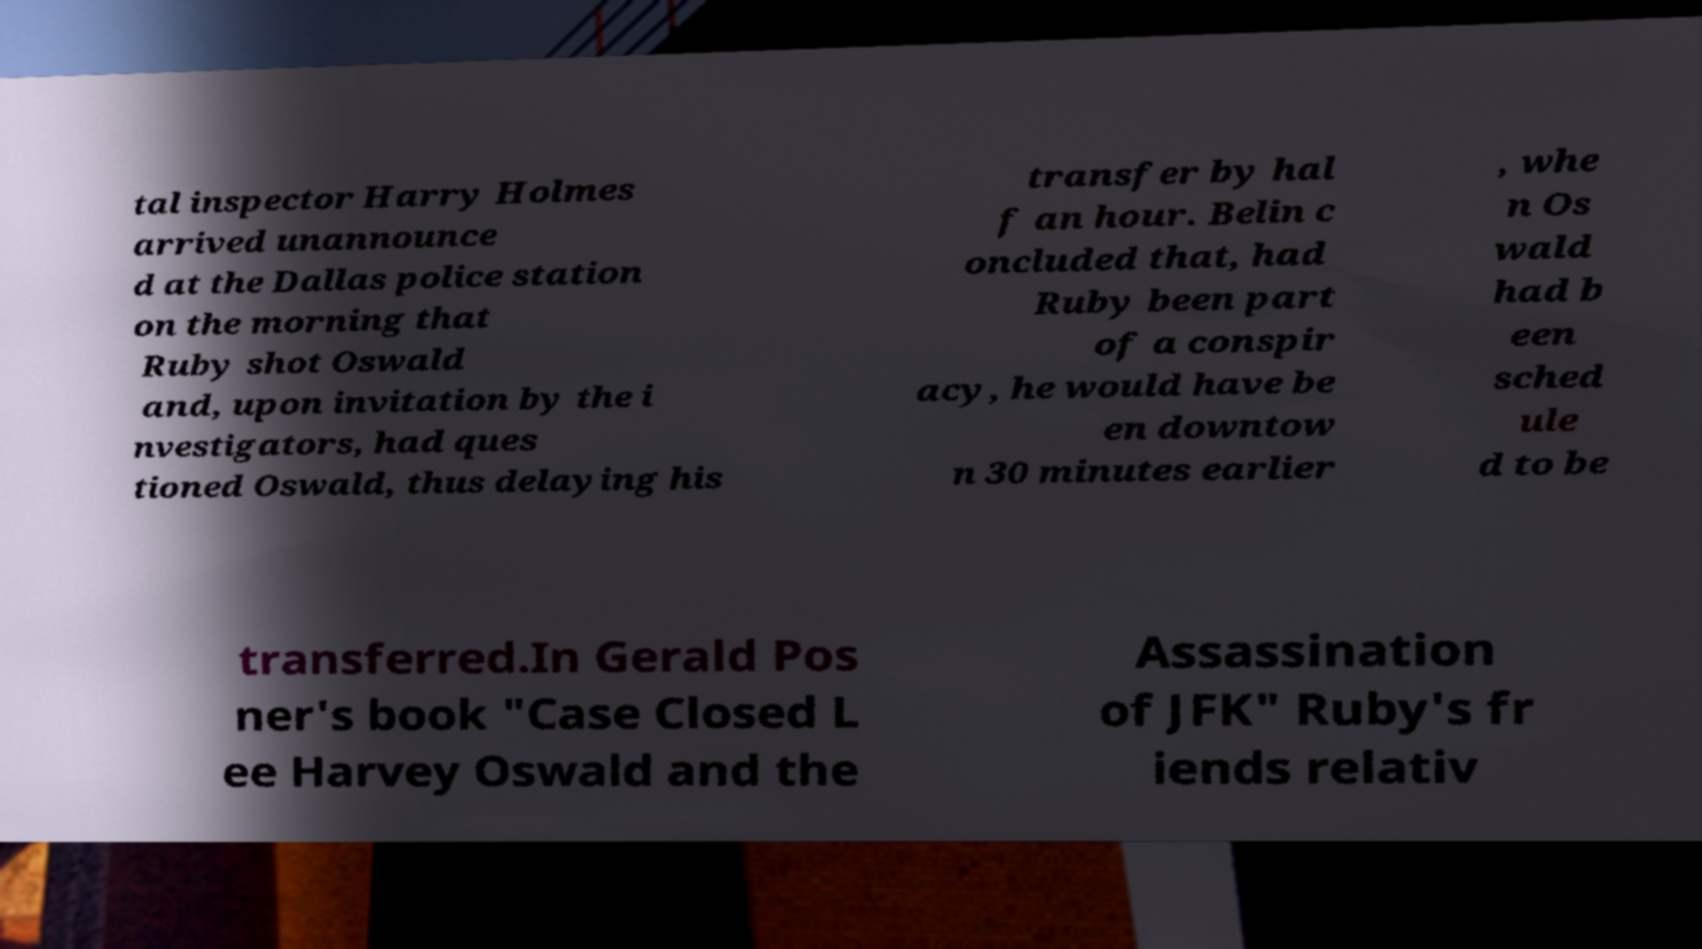What messages or text are displayed in this image? I need them in a readable, typed format. tal inspector Harry Holmes arrived unannounce d at the Dallas police station on the morning that Ruby shot Oswald and, upon invitation by the i nvestigators, had ques tioned Oswald, thus delaying his transfer by hal f an hour. Belin c oncluded that, had Ruby been part of a conspir acy, he would have be en downtow n 30 minutes earlier , whe n Os wald had b een sched ule d to be transferred.In Gerald Pos ner's book "Case Closed L ee Harvey Oswald and the Assassination of JFK" Ruby's fr iends relativ 